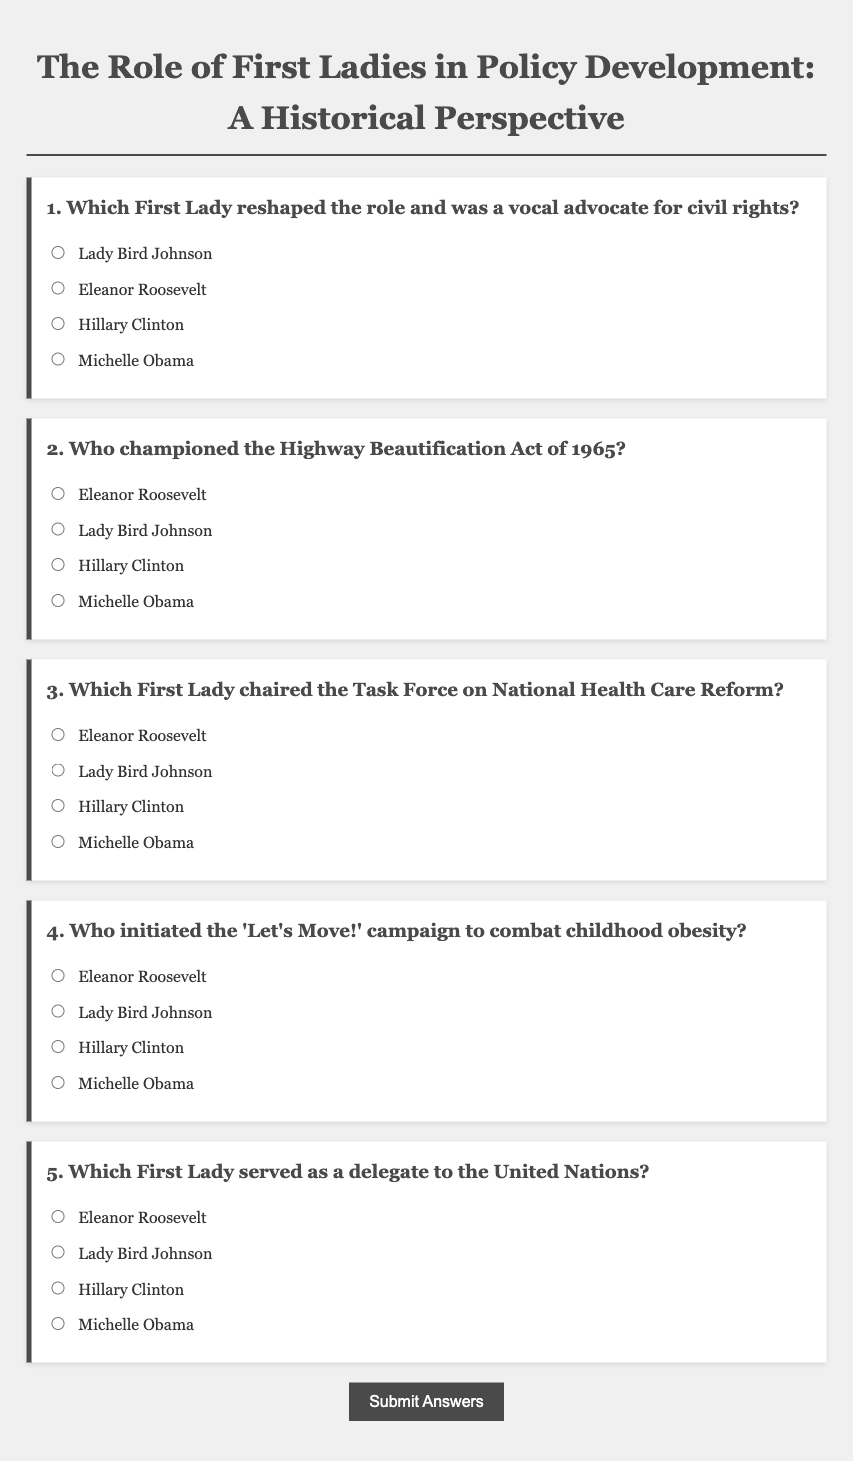Which term describes the main subject of the document? The title of the document indicates that it focuses on the role of First Ladies in policy development from a historical perspective.
Answer: The Role of First Ladies in Policy Development: A Historical Perspective How many questions are presented in the questionnaire? The document contains a questionnaire with a total of five different questions about First Ladies and their roles.
Answer: 5 Which First Lady is associated with the 'Let's Move!' campaign? The document explicitly states that Michelle Obama initiated the 'Let's Move!' campaign to combat childhood obesity.
Answer: Michelle Obama What significant act did Lady Bird Johnson champion? The second question in the document refers to the Highway Beautification Act of 1965, associated with Lady Bird Johnson.
Answer: Highway Beautification Act Which First Lady served as a delegate to the United Nations? According to the document, Eleanor Roosevelt is noted for serving as a delegate to the United Nations.
Answer: Eleanor Roosevelt Which question addresses health care reform? The third question mentions the Task Force on National Health Care Reform and relates it to a specific First Lady.
Answer: Which First Lady chaired the Task Force on National Health Care Reform? 